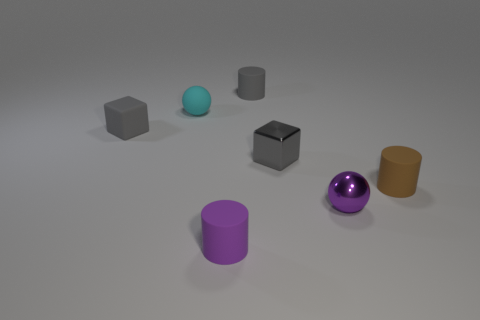Add 2 small gray blocks. How many objects exist? 9 Subtract all small brown cylinders. How many cylinders are left? 2 Subtract 1 balls. How many balls are left? 1 Add 3 brown objects. How many brown objects are left? 4 Add 3 tiny cubes. How many tiny cubes exist? 5 Subtract all cyan balls. How many balls are left? 1 Subtract 0 purple cubes. How many objects are left? 7 Subtract all cylinders. How many objects are left? 4 Subtract all gray cylinders. Subtract all brown cubes. How many cylinders are left? 2 Subtract all purple cubes. How many purple spheres are left? 1 